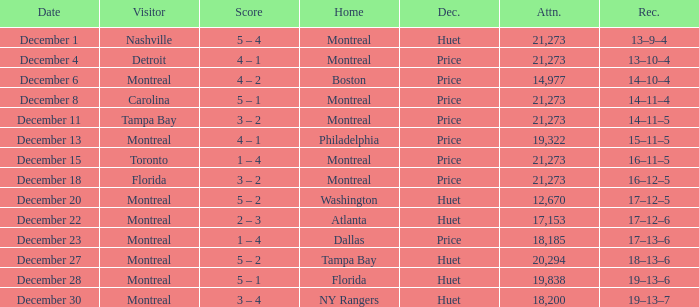What is the record on December 4? 13–10–4. 